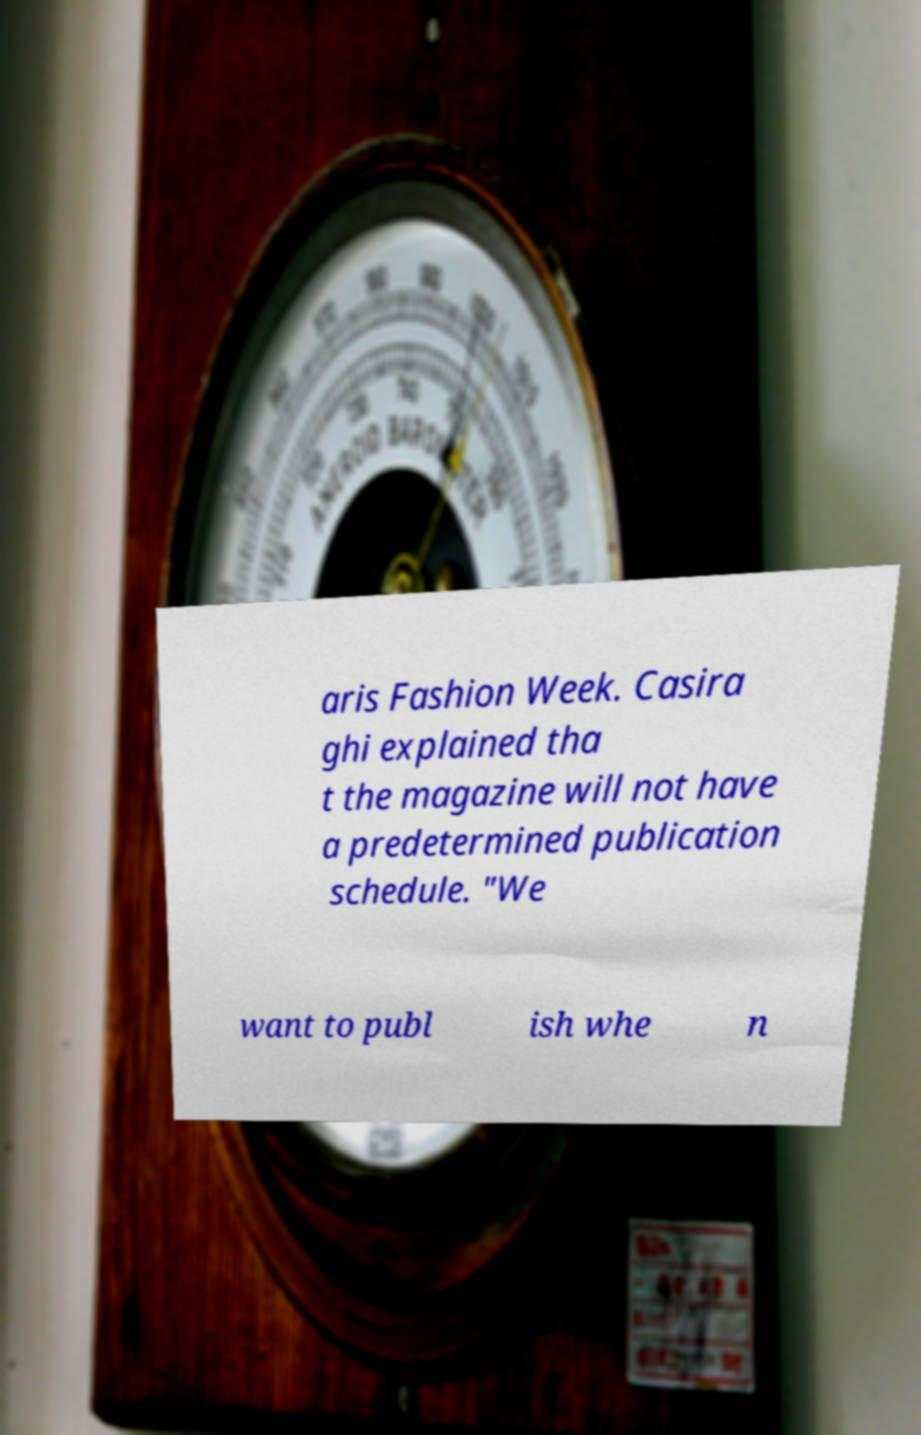Can you read and provide the text displayed in the image?This photo seems to have some interesting text. Can you extract and type it out for me? aris Fashion Week. Casira ghi explained tha t the magazine will not have a predetermined publication schedule. "We want to publ ish whe n 